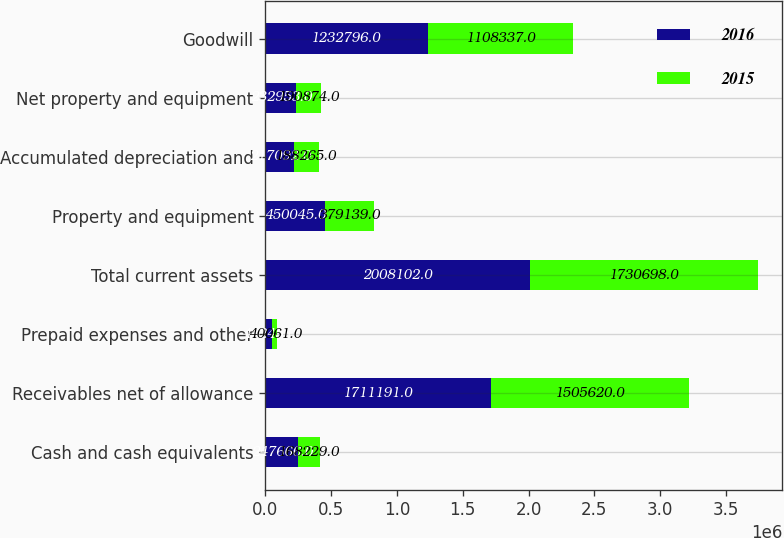Convert chart to OTSL. <chart><loc_0><loc_0><loc_500><loc_500><stacked_bar_chart><ecel><fcel>Cash and cash equivalents<fcel>Receivables net of allowance<fcel>Prepaid expenses and other<fcel>Total current assets<fcel>Property and equipment<fcel>Accumulated depreciation and<fcel>Net property and equipment<fcel>Goodwill<nl><fcel>2016<fcel>247666<fcel>1.71119e+06<fcel>49245<fcel>2.0081e+06<fcel>450045<fcel>217092<fcel>232953<fcel>1.2328e+06<nl><fcel>2015<fcel>168229<fcel>1.50562e+06<fcel>40061<fcel>1.7307e+06<fcel>379139<fcel>188265<fcel>190874<fcel>1.10834e+06<nl></chart> 